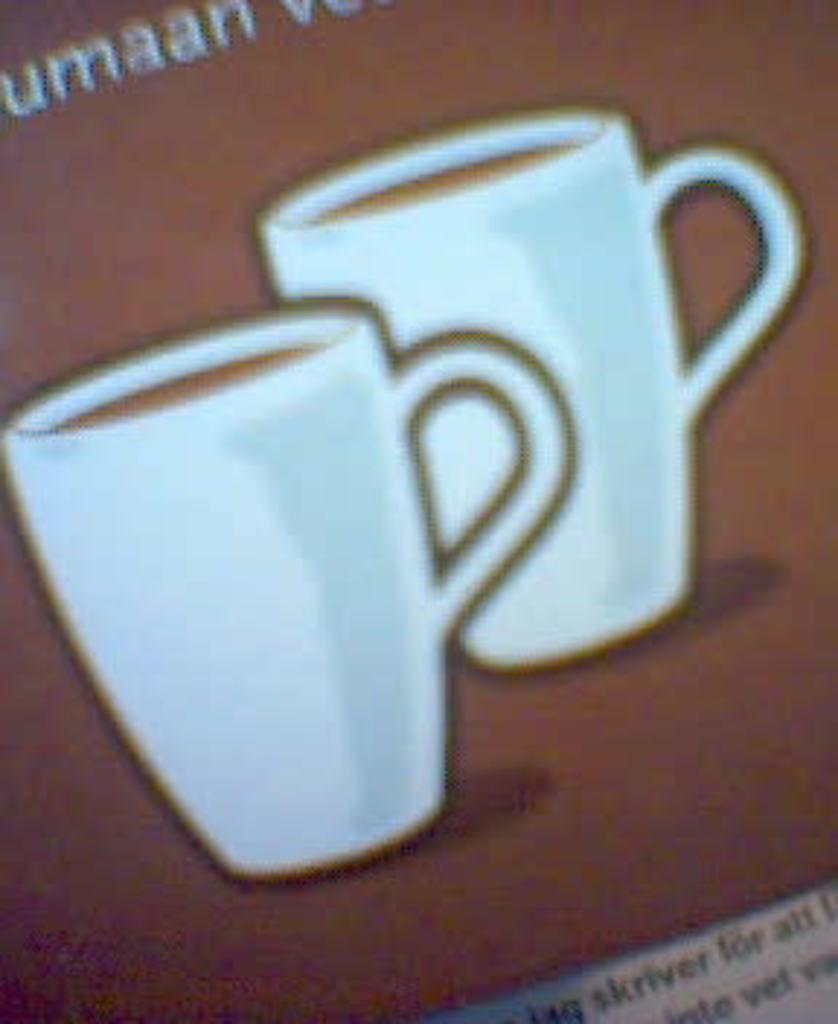What is the medium on which the image is created? The image is taken on paper. What can be seen in the image besides the cups? There is text in the image. How many cups are present in the image? There are two cups in the image. What is inside the cups? The cups contain coffee. What type of friction can be observed between the cups and the wall in the image? There is no wall present in the image, and therefore no friction between the cups and a wall can be observed. What role does zinc play in the image? There is no mention of zinc in the image, and therefore it does not play any role. 